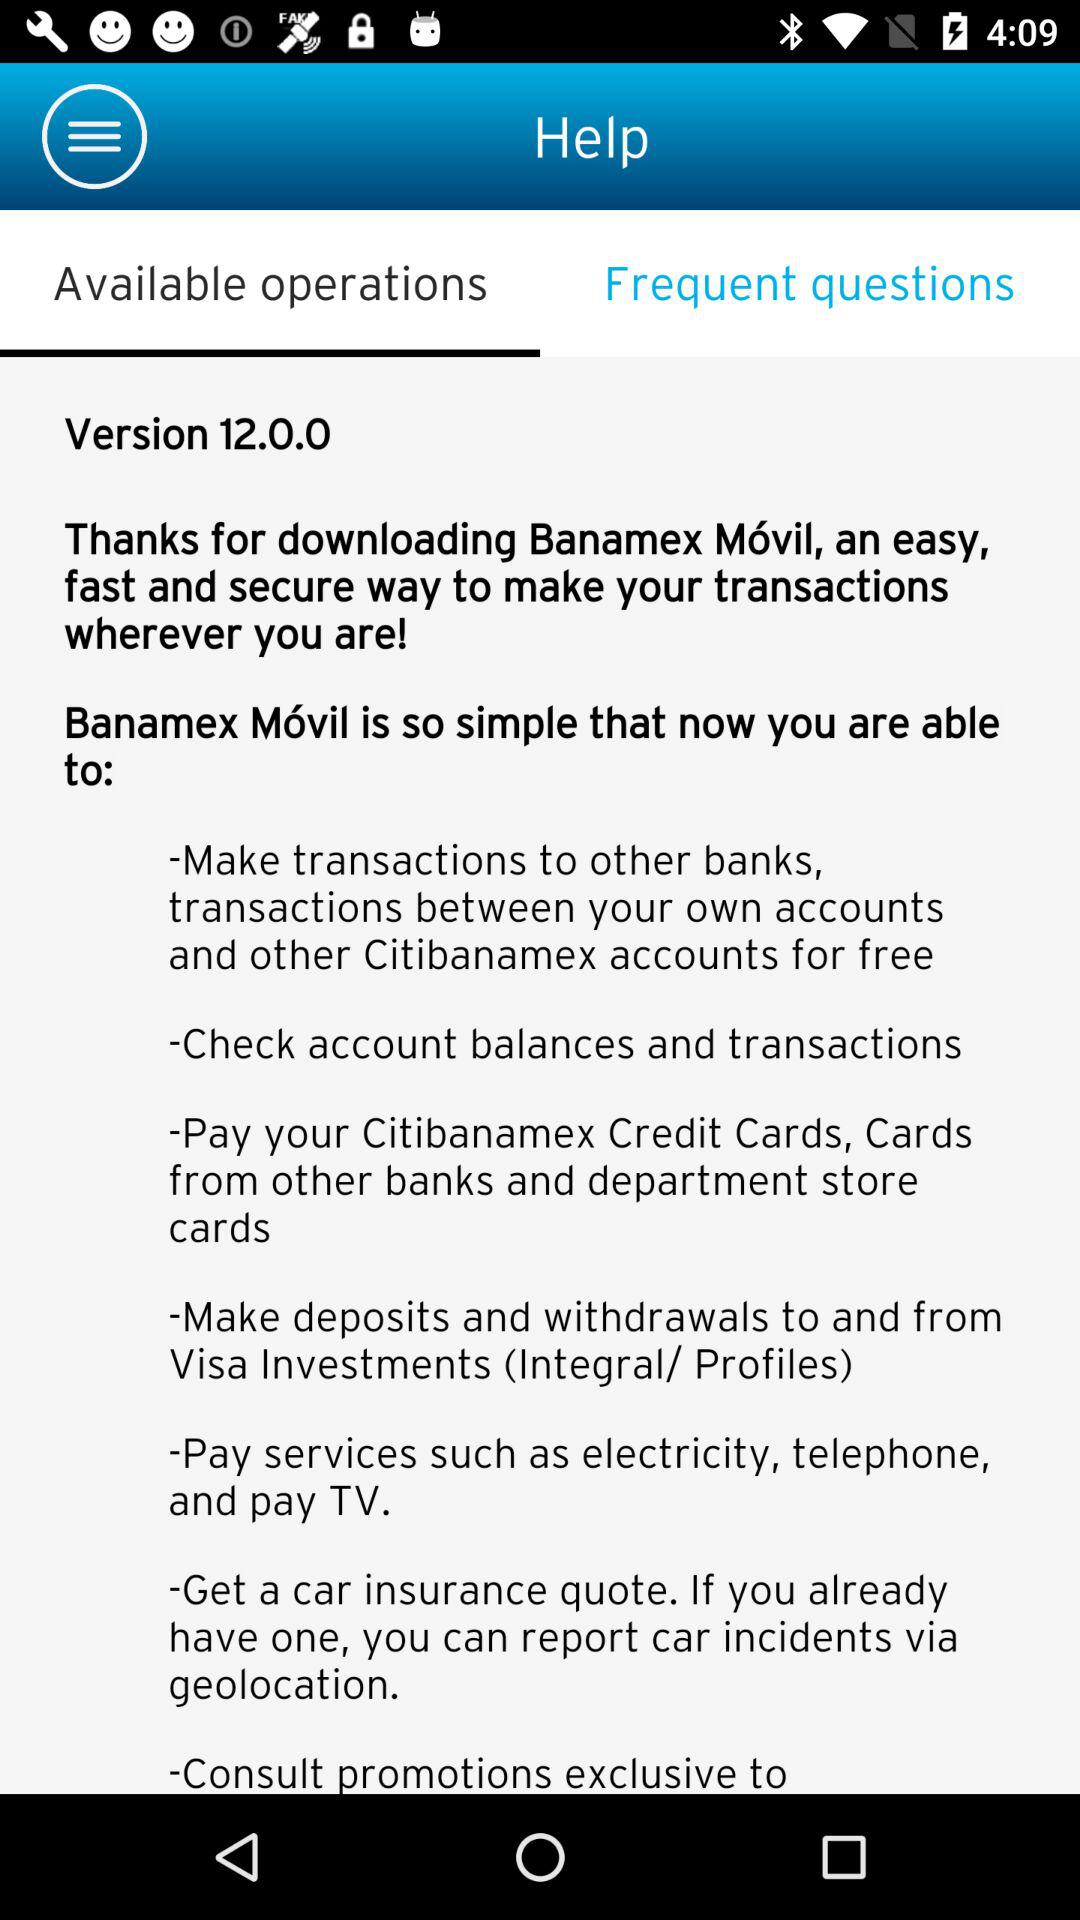Which tab has been selected? The tab "Available operations" has been selected. 